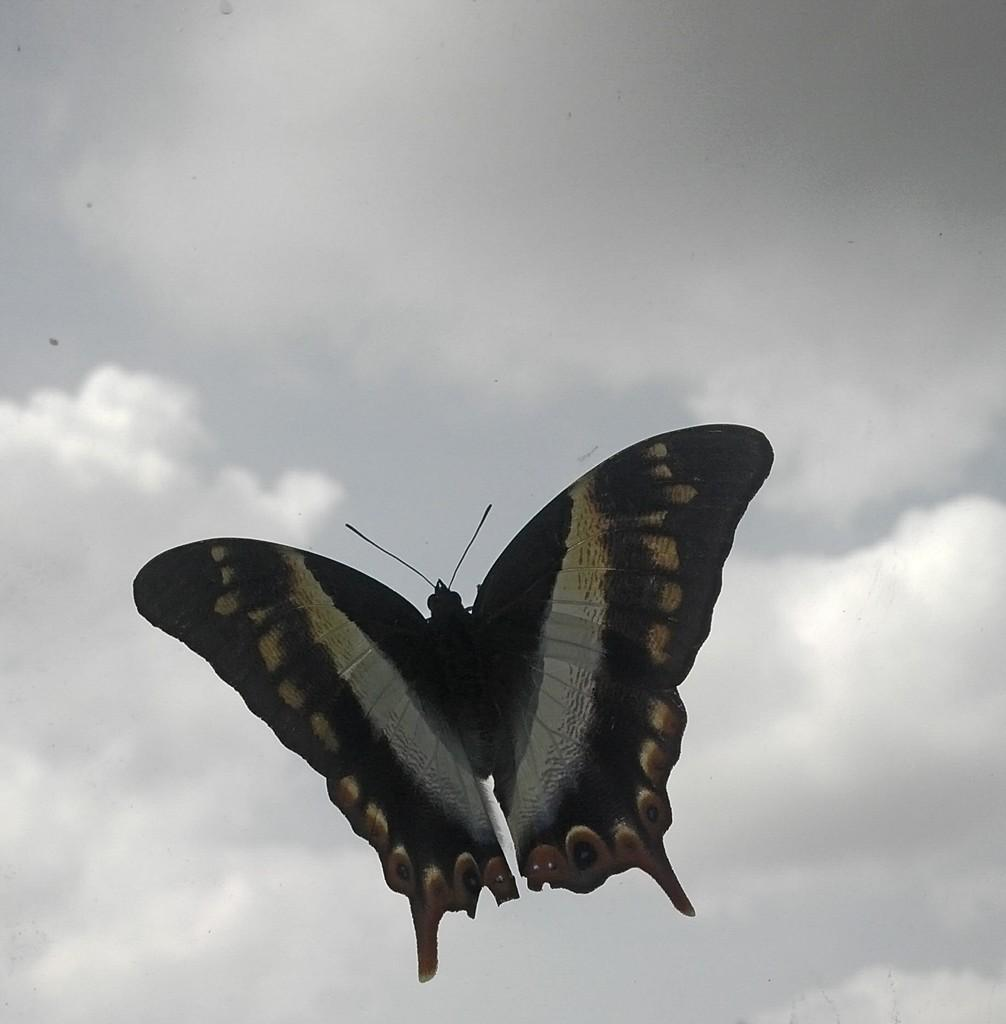What type of animal can be seen in the image? There is a butterfly in the image. What can be seen in the background of the image? The sky is visible in the background of the image. What type of insurance policy is the butterfly considering in the image? There is no indication in the image that the butterfly is considering any insurance policy. 